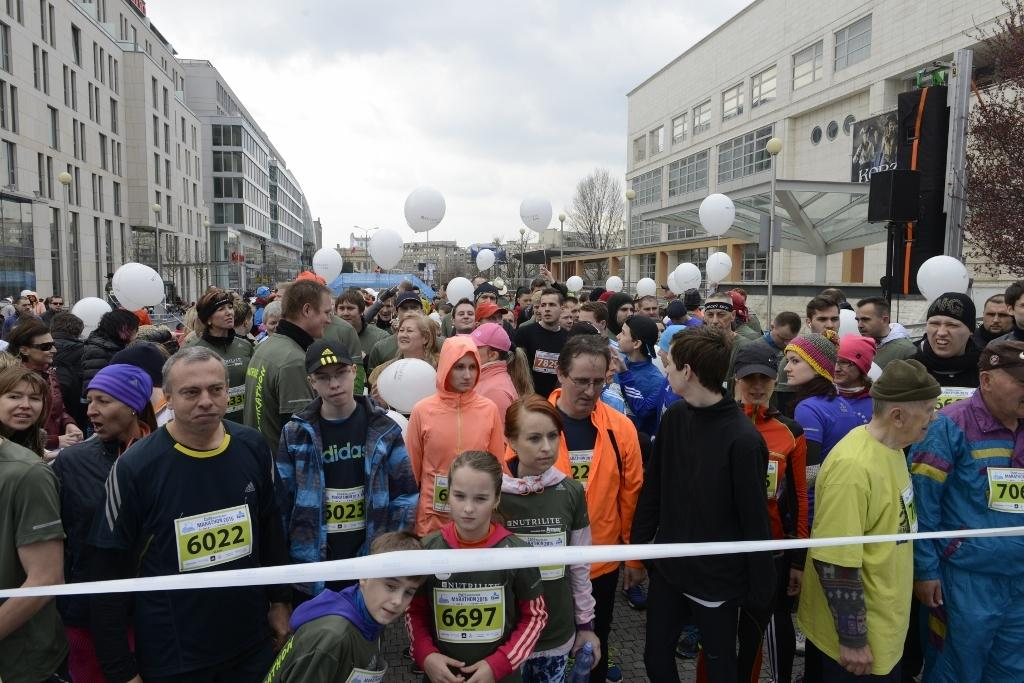Who or what can be seen in the image? There are people in the image. What else is present in the image besides people? There are balloons, buildings, trees, poles, a white-colored ribbon, and a black-colored object in the image. What can be seen in the sky in the image? The sky is visible in the image, and there are clouds in the sky. What language is being spoken by the people in the image? There is no indication of the language being spoken by the people in the image, as we cannot hear or see any speech. Can you see a knife in the image? No, there is no knife present in the image. 